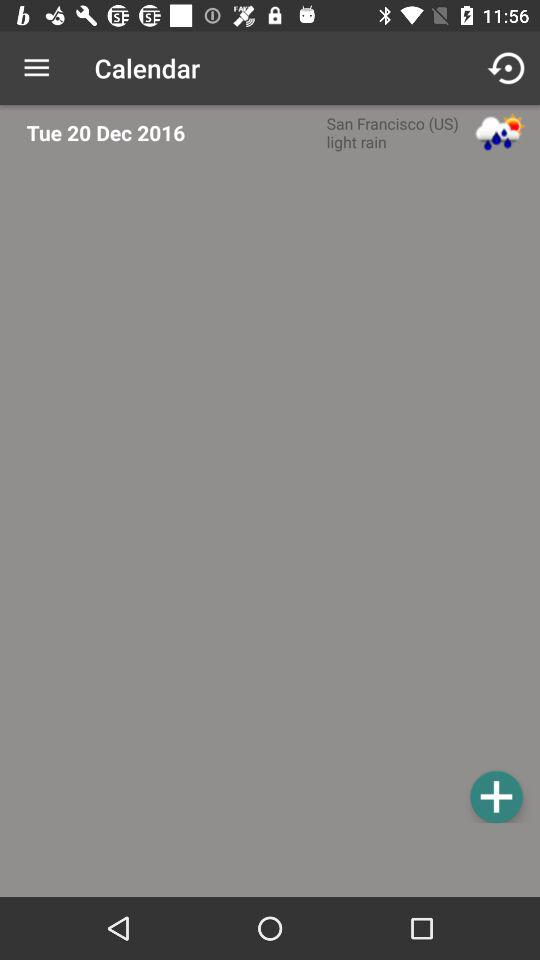What date is selected? The selected date is Tuesday, December 20, 2016. 